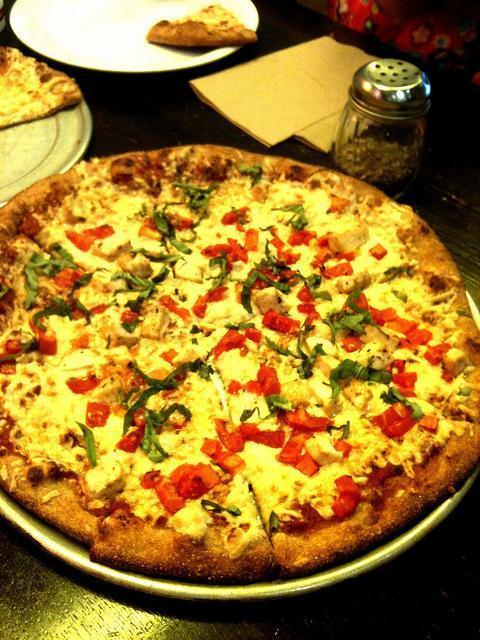How many pizzas are visible?
Give a very brief answer. 2. 